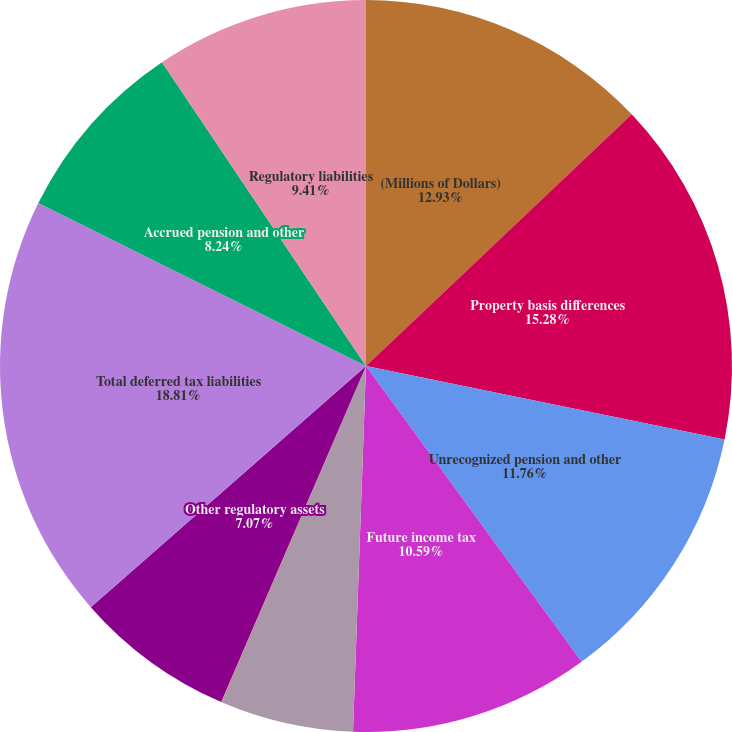<chart> <loc_0><loc_0><loc_500><loc_500><pie_chart><fcel>(Millions of Dollars)<fcel>Property basis differences<fcel>Unrecognized pension and other<fcel>Future income tax<fcel>Environmental remediation<fcel>Deferred storm costs<fcel>Other regulatory assets<fcel>Total deferred tax liabilities<fcel>Accrued pension and other<fcel>Regulatory liabilities<nl><fcel>12.93%<fcel>15.28%<fcel>11.76%<fcel>10.59%<fcel>5.89%<fcel>0.02%<fcel>7.07%<fcel>18.8%<fcel>8.24%<fcel>9.41%<nl></chart> 